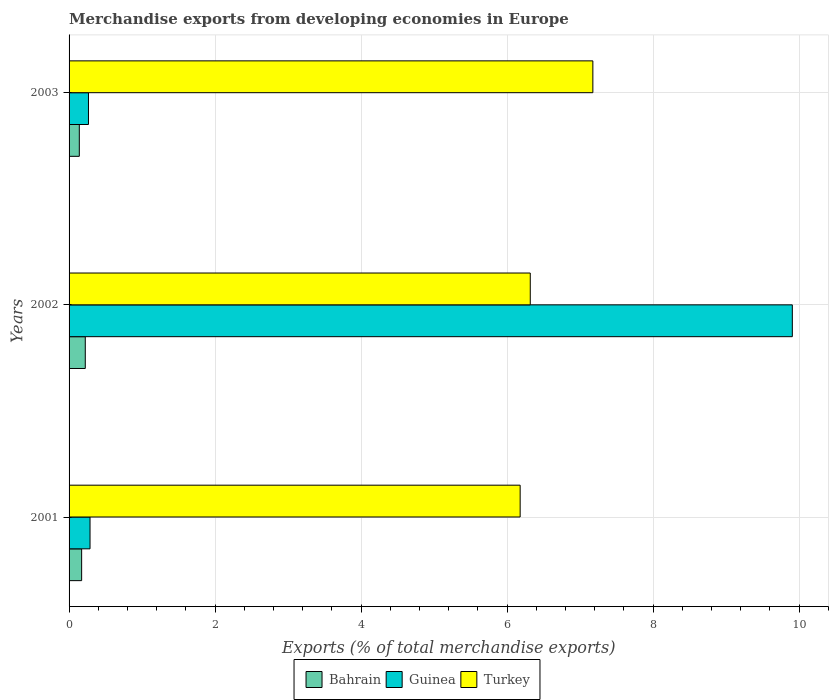How many different coloured bars are there?
Provide a short and direct response. 3. How many groups of bars are there?
Ensure brevity in your answer.  3. Are the number of bars per tick equal to the number of legend labels?
Provide a succinct answer. Yes. What is the label of the 2nd group of bars from the top?
Give a very brief answer. 2002. What is the percentage of total merchandise exports in Guinea in 2001?
Offer a terse response. 0.29. Across all years, what is the maximum percentage of total merchandise exports in Bahrain?
Your answer should be very brief. 0.22. Across all years, what is the minimum percentage of total merchandise exports in Turkey?
Provide a succinct answer. 6.18. In which year was the percentage of total merchandise exports in Guinea maximum?
Your answer should be very brief. 2002. What is the total percentage of total merchandise exports in Guinea in the graph?
Keep it short and to the point. 10.46. What is the difference between the percentage of total merchandise exports in Guinea in 2001 and that in 2002?
Your answer should be very brief. -9.62. What is the difference between the percentage of total merchandise exports in Turkey in 2001 and the percentage of total merchandise exports in Bahrain in 2002?
Offer a very short reply. 5.96. What is the average percentage of total merchandise exports in Guinea per year?
Ensure brevity in your answer.  3.49. In the year 2003, what is the difference between the percentage of total merchandise exports in Bahrain and percentage of total merchandise exports in Guinea?
Give a very brief answer. -0.13. What is the ratio of the percentage of total merchandise exports in Guinea in 2001 to that in 2002?
Your answer should be compact. 0.03. Is the difference between the percentage of total merchandise exports in Bahrain in 2001 and 2003 greater than the difference between the percentage of total merchandise exports in Guinea in 2001 and 2003?
Your response must be concise. Yes. What is the difference between the highest and the second highest percentage of total merchandise exports in Turkey?
Ensure brevity in your answer.  0.86. What is the difference between the highest and the lowest percentage of total merchandise exports in Turkey?
Your response must be concise. 1. Is the sum of the percentage of total merchandise exports in Turkey in 2001 and 2002 greater than the maximum percentage of total merchandise exports in Bahrain across all years?
Your response must be concise. Yes. What does the 2nd bar from the bottom in 2002 represents?
Offer a very short reply. Guinea. How many bars are there?
Your response must be concise. 9. Are all the bars in the graph horizontal?
Provide a succinct answer. Yes. Does the graph contain any zero values?
Make the answer very short. No. Does the graph contain grids?
Offer a terse response. Yes. Where does the legend appear in the graph?
Your answer should be compact. Bottom center. What is the title of the graph?
Your answer should be compact. Merchandise exports from developing economies in Europe. Does "Pacific island small states" appear as one of the legend labels in the graph?
Keep it short and to the point. No. What is the label or title of the X-axis?
Keep it short and to the point. Exports (% of total merchandise exports). What is the Exports (% of total merchandise exports) in Bahrain in 2001?
Offer a very short reply. 0.17. What is the Exports (% of total merchandise exports) in Guinea in 2001?
Your response must be concise. 0.29. What is the Exports (% of total merchandise exports) of Turkey in 2001?
Provide a succinct answer. 6.18. What is the Exports (% of total merchandise exports) of Bahrain in 2002?
Your response must be concise. 0.22. What is the Exports (% of total merchandise exports) of Guinea in 2002?
Offer a terse response. 9.91. What is the Exports (% of total merchandise exports) of Turkey in 2002?
Provide a short and direct response. 6.32. What is the Exports (% of total merchandise exports) of Bahrain in 2003?
Your answer should be very brief. 0.14. What is the Exports (% of total merchandise exports) of Guinea in 2003?
Offer a very short reply. 0.27. What is the Exports (% of total merchandise exports) in Turkey in 2003?
Make the answer very short. 7.17. Across all years, what is the maximum Exports (% of total merchandise exports) in Bahrain?
Keep it short and to the point. 0.22. Across all years, what is the maximum Exports (% of total merchandise exports) of Guinea?
Your answer should be compact. 9.91. Across all years, what is the maximum Exports (% of total merchandise exports) in Turkey?
Your response must be concise. 7.17. Across all years, what is the minimum Exports (% of total merchandise exports) in Bahrain?
Offer a very short reply. 0.14. Across all years, what is the minimum Exports (% of total merchandise exports) in Guinea?
Provide a short and direct response. 0.27. Across all years, what is the minimum Exports (% of total merchandise exports) of Turkey?
Make the answer very short. 6.18. What is the total Exports (% of total merchandise exports) in Bahrain in the graph?
Ensure brevity in your answer.  0.53. What is the total Exports (% of total merchandise exports) in Guinea in the graph?
Offer a terse response. 10.46. What is the total Exports (% of total merchandise exports) in Turkey in the graph?
Offer a terse response. 19.67. What is the difference between the Exports (% of total merchandise exports) of Bahrain in 2001 and that in 2002?
Make the answer very short. -0.05. What is the difference between the Exports (% of total merchandise exports) in Guinea in 2001 and that in 2002?
Offer a terse response. -9.62. What is the difference between the Exports (% of total merchandise exports) in Turkey in 2001 and that in 2002?
Offer a terse response. -0.14. What is the difference between the Exports (% of total merchandise exports) in Bahrain in 2001 and that in 2003?
Your answer should be very brief. 0.03. What is the difference between the Exports (% of total merchandise exports) of Guinea in 2001 and that in 2003?
Keep it short and to the point. 0.02. What is the difference between the Exports (% of total merchandise exports) in Turkey in 2001 and that in 2003?
Your response must be concise. -1. What is the difference between the Exports (% of total merchandise exports) in Bahrain in 2002 and that in 2003?
Your answer should be very brief. 0.08. What is the difference between the Exports (% of total merchandise exports) in Guinea in 2002 and that in 2003?
Ensure brevity in your answer.  9.64. What is the difference between the Exports (% of total merchandise exports) of Turkey in 2002 and that in 2003?
Keep it short and to the point. -0.86. What is the difference between the Exports (% of total merchandise exports) of Bahrain in 2001 and the Exports (% of total merchandise exports) of Guinea in 2002?
Give a very brief answer. -9.73. What is the difference between the Exports (% of total merchandise exports) in Bahrain in 2001 and the Exports (% of total merchandise exports) in Turkey in 2002?
Your response must be concise. -6.15. What is the difference between the Exports (% of total merchandise exports) in Guinea in 2001 and the Exports (% of total merchandise exports) in Turkey in 2002?
Your answer should be compact. -6.03. What is the difference between the Exports (% of total merchandise exports) in Bahrain in 2001 and the Exports (% of total merchandise exports) in Guinea in 2003?
Make the answer very short. -0.09. What is the difference between the Exports (% of total merchandise exports) of Bahrain in 2001 and the Exports (% of total merchandise exports) of Turkey in 2003?
Your answer should be compact. -7. What is the difference between the Exports (% of total merchandise exports) in Guinea in 2001 and the Exports (% of total merchandise exports) in Turkey in 2003?
Offer a terse response. -6.89. What is the difference between the Exports (% of total merchandise exports) in Bahrain in 2002 and the Exports (% of total merchandise exports) in Guinea in 2003?
Provide a short and direct response. -0.04. What is the difference between the Exports (% of total merchandise exports) of Bahrain in 2002 and the Exports (% of total merchandise exports) of Turkey in 2003?
Provide a succinct answer. -6.95. What is the difference between the Exports (% of total merchandise exports) in Guinea in 2002 and the Exports (% of total merchandise exports) in Turkey in 2003?
Your response must be concise. 2.73. What is the average Exports (% of total merchandise exports) in Bahrain per year?
Provide a short and direct response. 0.18. What is the average Exports (% of total merchandise exports) of Guinea per year?
Your response must be concise. 3.49. What is the average Exports (% of total merchandise exports) in Turkey per year?
Provide a succinct answer. 6.56. In the year 2001, what is the difference between the Exports (% of total merchandise exports) of Bahrain and Exports (% of total merchandise exports) of Guinea?
Your answer should be very brief. -0.11. In the year 2001, what is the difference between the Exports (% of total merchandise exports) in Bahrain and Exports (% of total merchandise exports) in Turkey?
Provide a succinct answer. -6.01. In the year 2001, what is the difference between the Exports (% of total merchandise exports) of Guinea and Exports (% of total merchandise exports) of Turkey?
Make the answer very short. -5.89. In the year 2002, what is the difference between the Exports (% of total merchandise exports) in Bahrain and Exports (% of total merchandise exports) in Guinea?
Your response must be concise. -9.69. In the year 2002, what is the difference between the Exports (% of total merchandise exports) in Bahrain and Exports (% of total merchandise exports) in Turkey?
Ensure brevity in your answer.  -6.1. In the year 2002, what is the difference between the Exports (% of total merchandise exports) of Guinea and Exports (% of total merchandise exports) of Turkey?
Your response must be concise. 3.59. In the year 2003, what is the difference between the Exports (% of total merchandise exports) in Bahrain and Exports (% of total merchandise exports) in Guinea?
Your response must be concise. -0.13. In the year 2003, what is the difference between the Exports (% of total merchandise exports) in Bahrain and Exports (% of total merchandise exports) in Turkey?
Provide a succinct answer. -7.03. In the year 2003, what is the difference between the Exports (% of total merchandise exports) of Guinea and Exports (% of total merchandise exports) of Turkey?
Offer a very short reply. -6.91. What is the ratio of the Exports (% of total merchandise exports) of Bahrain in 2001 to that in 2002?
Make the answer very short. 0.78. What is the ratio of the Exports (% of total merchandise exports) of Guinea in 2001 to that in 2002?
Provide a succinct answer. 0.03. What is the ratio of the Exports (% of total merchandise exports) of Turkey in 2001 to that in 2002?
Offer a terse response. 0.98. What is the ratio of the Exports (% of total merchandise exports) in Bahrain in 2001 to that in 2003?
Provide a succinct answer. 1.23. What is the ratio of the Exports (% of total merchandise exports) of Guinea in 2001 to that in 2003?
Your answer should be compact. 1.08. What is the ratio of the Exports (% of total merchandise exports) of Turkey in 2001 to that in 2003?
Keep it short and to the point. 0.86. What is the ratio of the Exports (% of total merchandise exports) in Bahrain in 2002 to that in 2003?
Ensure brevity in your answer.  1.58. What is the ratio of the Exports (% of total merchandise exports) in Guinea in 2002 to that in 2003?
Provide a short and direct response. 37.3. What is the ratio of the Exports (% of total merchandise exports) in Turkey in 2002 to that in 2003?
Ensure brevity in your answer.  0.88. What is the difference between the highest and the second highest Exports (% of total merchandise exports) of Bahrain?
Make the answer very short. 0.05. What is the difference between the highest and the second highest Exports (% of total merchandise exports) in Guinea?
Make the answer very short. 9.62. What is the difference between the highest and the second highest Exports (% of total merchandise exports) of Turkey?
Your response must be concise. 0.86. What is the difference between the highest and the lowest Exports (% of total merchandise exports) in Bahrain?
Offer a terse response. 0.08. What is the difference between the highest and the lowest Exports (% of total merchandise exports) in Guinea?
Offer a very short reply. 9.64. What is the difference between the highest and the lowest Exports (% of total merchandise exports) in Turkey?
Offer a terse response. 1. 